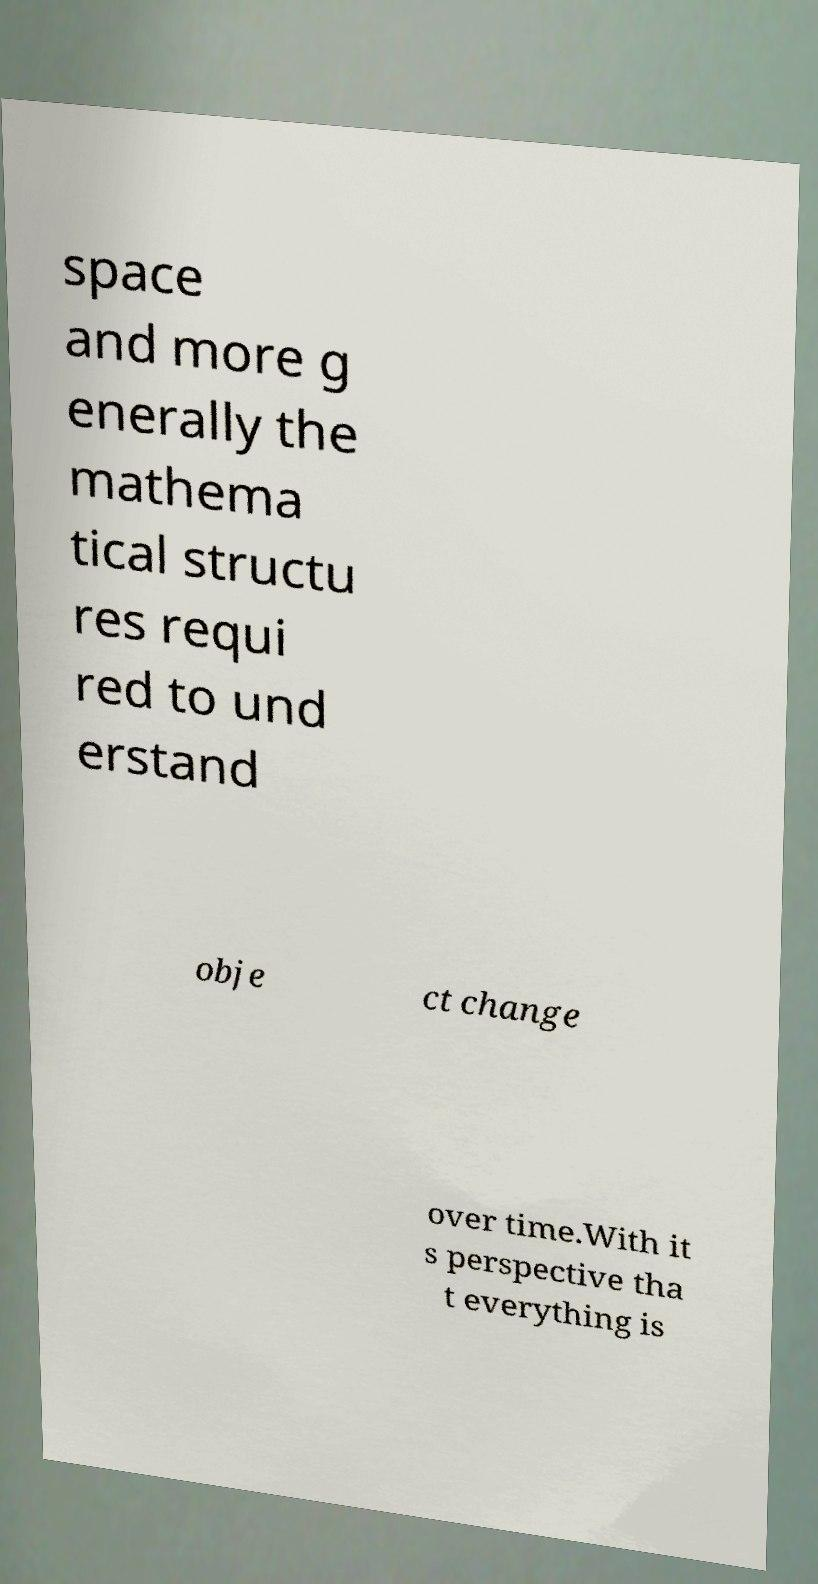Could you extract and type out the text from this image? space and more g enerally the mathema tical structu res requi red to und erstand obje ct change over time.With it s perspective tha t everything is 